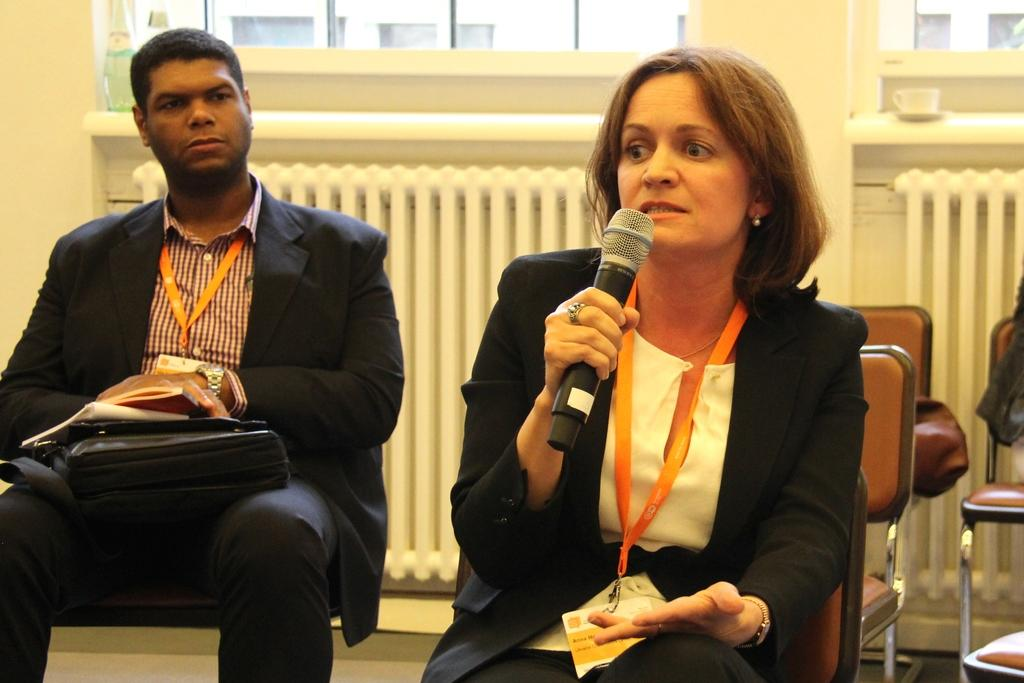How many people are in the image? There are two persons in the image. What are the persons doing in the image? Both persons are sitting on chairs. What is the woman holding in the image? The woman is holding a mic. Can you see any geese swimming in the water near the persons in the image? There is no water or geese present in the image; it features two people sitting on chairs. 